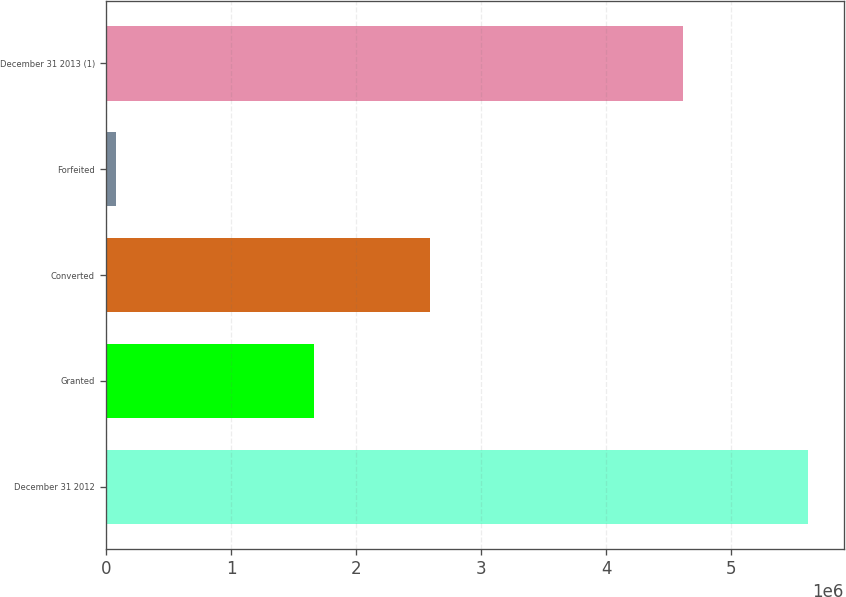Convert chart. <chart><loc_0><loc_0><loc_500><loc_500><bar_chart><fcel>December 31 2012<fcel>Granted<fcel>Converted<fcel>Forfeited<fcel>December 31 2013 (1)<nl><fcel>5.62084e+06<fcel>1.66053e+06<fcel>2.58864e+06<fcel>79917<fcel>4.61281e+06<nl></chart> 